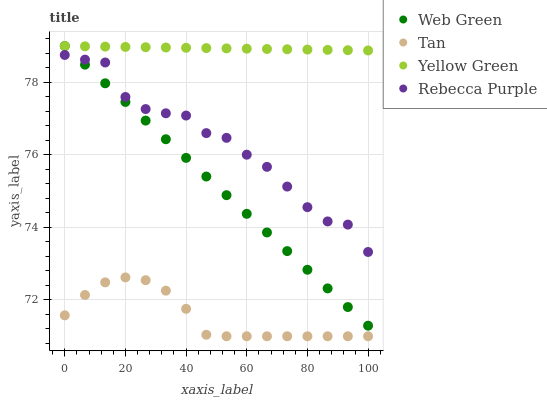Does Tan have the minimum area under the curve?
Answer yes or no. Yes. Does Yellow Green have the maximum area under the curve?
Answer yes or no. Yes. Does Web Green have the minimum area under the curve?
Answer yes or no. No. Does Web Green have the maximum area under the curve?
Answer yes or no. No. Is Web Green the smoothest?
Answer yes or no. Yes. Is Rebecca Purple the roughest?
Answer yes or no. Yes. Is Yellow Green the smoothest?
Answer yes or no. No. Is Yellow Green the roughest?
Answer yes or no. No. Does Tan have the lowest value?
Answer yes or no. Yes. Does Web Green have the lowest value?
Answer yes or no. No. Does Web Green have the highest value?
Answer yes or no. Yes. Does Rebecca Purple have the highest value?
Answer yes or no. No. Is Rebecca Purple less than Yellow Green?
Answer yes or no. Yes. Is Yellow Green greater than Tan?
Answer yes or no. Yes. Does Rebecca Purple intersect Web Green?
Answer yes or no. Yes. Is Rebecca Purple less than Web Green?
Answer yes or no. No. Is Rebecca Purple greater than Web Green?
Answer yes or no. No. Does Rebecca Purple intersect Yellow Green?
Answer yes or no. No. 